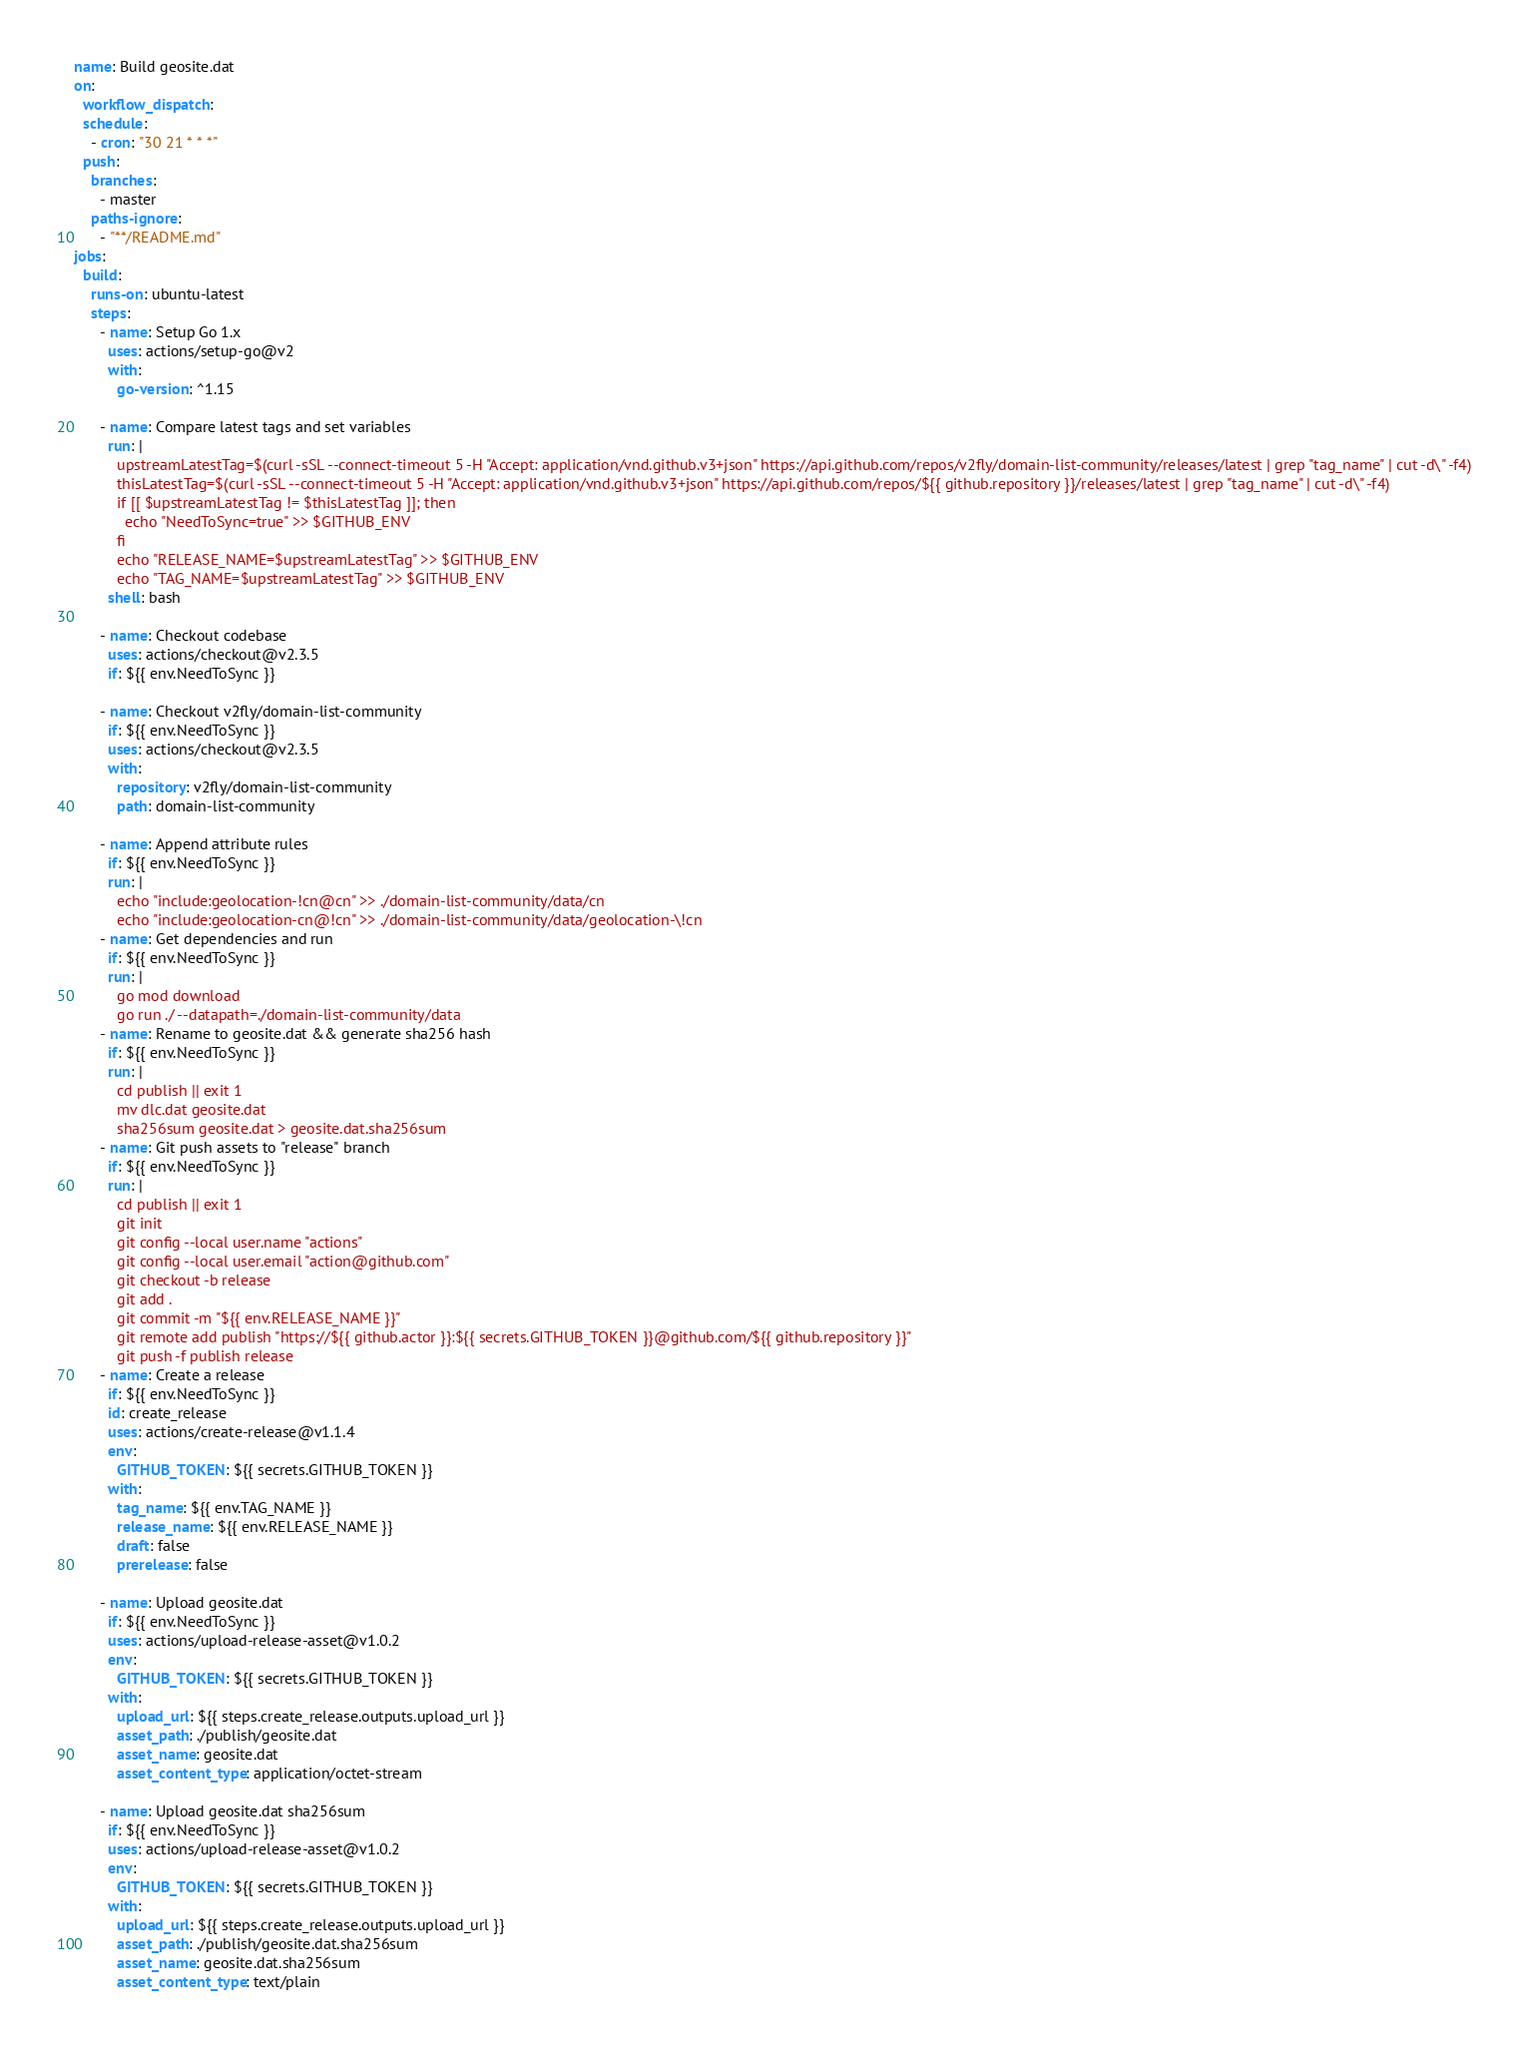Convert code to text. <code><loc_0><loc_0><loc_500><loc_500><_YAML_>name: Build geosite.dat
on:
  workflow_dispatch:
  schedule:
    - cron: "30 21 * * *"
  push:
    branches:
      - master
    paths-ignore:
      - "**/README.md"
jobs:
  build:
    runs-on: ubuntu-latest
    steps:
      - name: Setup Go 1.x
        uses: actions/setup-go@v2
        with:
          go-version: ^1.15

      - name: Compare latest tags and set variables
        run: |
          upstreamLatestTag=$(curl -sSL --connect-timeout 5 -H "Accept: application/vnd.github.v3+json" https://api.github.com/repos/v2fly/domain-list-community/releases/latest | grep "tag_name" | cut -d\" -f4)
          thisLatestTag=$(curl -sSL --connect-timeout 5 -H "Accept: application/vnd.github.v3+json" https://api.github.com/repos/${{ github.repository }}/releases/latest | grep "tag_name" | cut -d\" -f4)
          if [[ $upstreamLatestTag != $thisLatestTag ]]; then
            echo "NeedToSync=true" >> $GITHUB_ENV
          fi
          echo "RELEASE_NAME=$upstreamLatestTag" >> $GITHUB_ENV
          echo "TAG_NAME=$upstreamLatestTag" >> $GITHUB_ENV
        shell: bash

      - name: Checkout codebase
        uses: actions/checkout@v2.3.5
        if: ${{ env.NeedToSync }}

      - name: Checkout v2fly/domain-list-community
        if: ${{ env.NeedToSync }}
        uses: actions/checkout@v2.3.5
        with:
          repository: v2fly/domain-list-community
          path: domain-list-community

      - name: Append attribute rules
        if: ${{ env.NeedToSync }}
        run: |
          echo "include:geolocation-!cn@cn" >> ./domain-list-community/data/cn
          echo "include:geolocation-cn@!cn" >> ./domain-list-community/data/geolocation-\!cn
      - name: Get dependencies and run
        if: ${{ env.NeedToSync }}
        run: |
          go mod download
          go run ./ --datapath=./domain-list-community/data
      - name: Rename to geosite.dat && generate sha256 hash
        if: ${{ env.NeedToSync }}
        run: |
          cd publish || exit 1
          mv dlc.dat geosite.dat
          sha256sum geosite.dat > geosite.dat.sha256sum
      - name: Git push assets to "release" branch
        if: ${{ env.NeedToSync }}
        run: |
          cd publish || exit 1
          git init
          git config --local user.name "actions"
          git config --local user.email "action@github.com"
          git checkout -b release
          git add .
          git commit -m "${{ env.RELEASE_NAME }}"
          git remote add publish "https://${{ github.actor }}:${{ secrets.GITHUB_TOKEN }}@github.com/${{ github.repository }}"
          git push -f publish release
      - name: Create a release
        if: ${{ env.NeedToSync }}
        id: create_release
        uses: actions/create-release@v1.1.4
        env:
          GITHUB_TOKEN: ${{ secrets.GITHUB_TOKEN }}
        with:
          tag_name: ${{ env.TAG_NAME }}
          release_name: ${{ env.RELEASE_NAME }}
          draft: false
          prerelease: false

      - name: Upload geosite.dat
        if: ${{ env.NeedToSync }}
        uses: actions/upload-release-asset@v1.0.2
        env:
          GITHUB_TOKEN: ${{ secrets.GITHUB_TOKEN }}
        with:
          upload_url: ${{ steps.create_release.outputs.upload_url }}
          asset_path: ./publish/geosite.dat
          asset_name: geosite.dat
          asset_content_type: application/octet-stream

      - name: Upload geosite.dat sha256sum
        if: ${{ env.NeedToSync }}
        uses: actions/upload-release-asset@v1.0.2
        env:
          GITHUB_TOKEN: ${{ secrets.GITHUB_TOKEN }}
        with:
          upload_url: ${{ steps.create_release.outputs.upload_url }}
          asset_path: ./publish/geosite.dat.sha256sum
          asset_name: geosite.dat.sha256sum
          asset_content_type: text/plain
</code> 